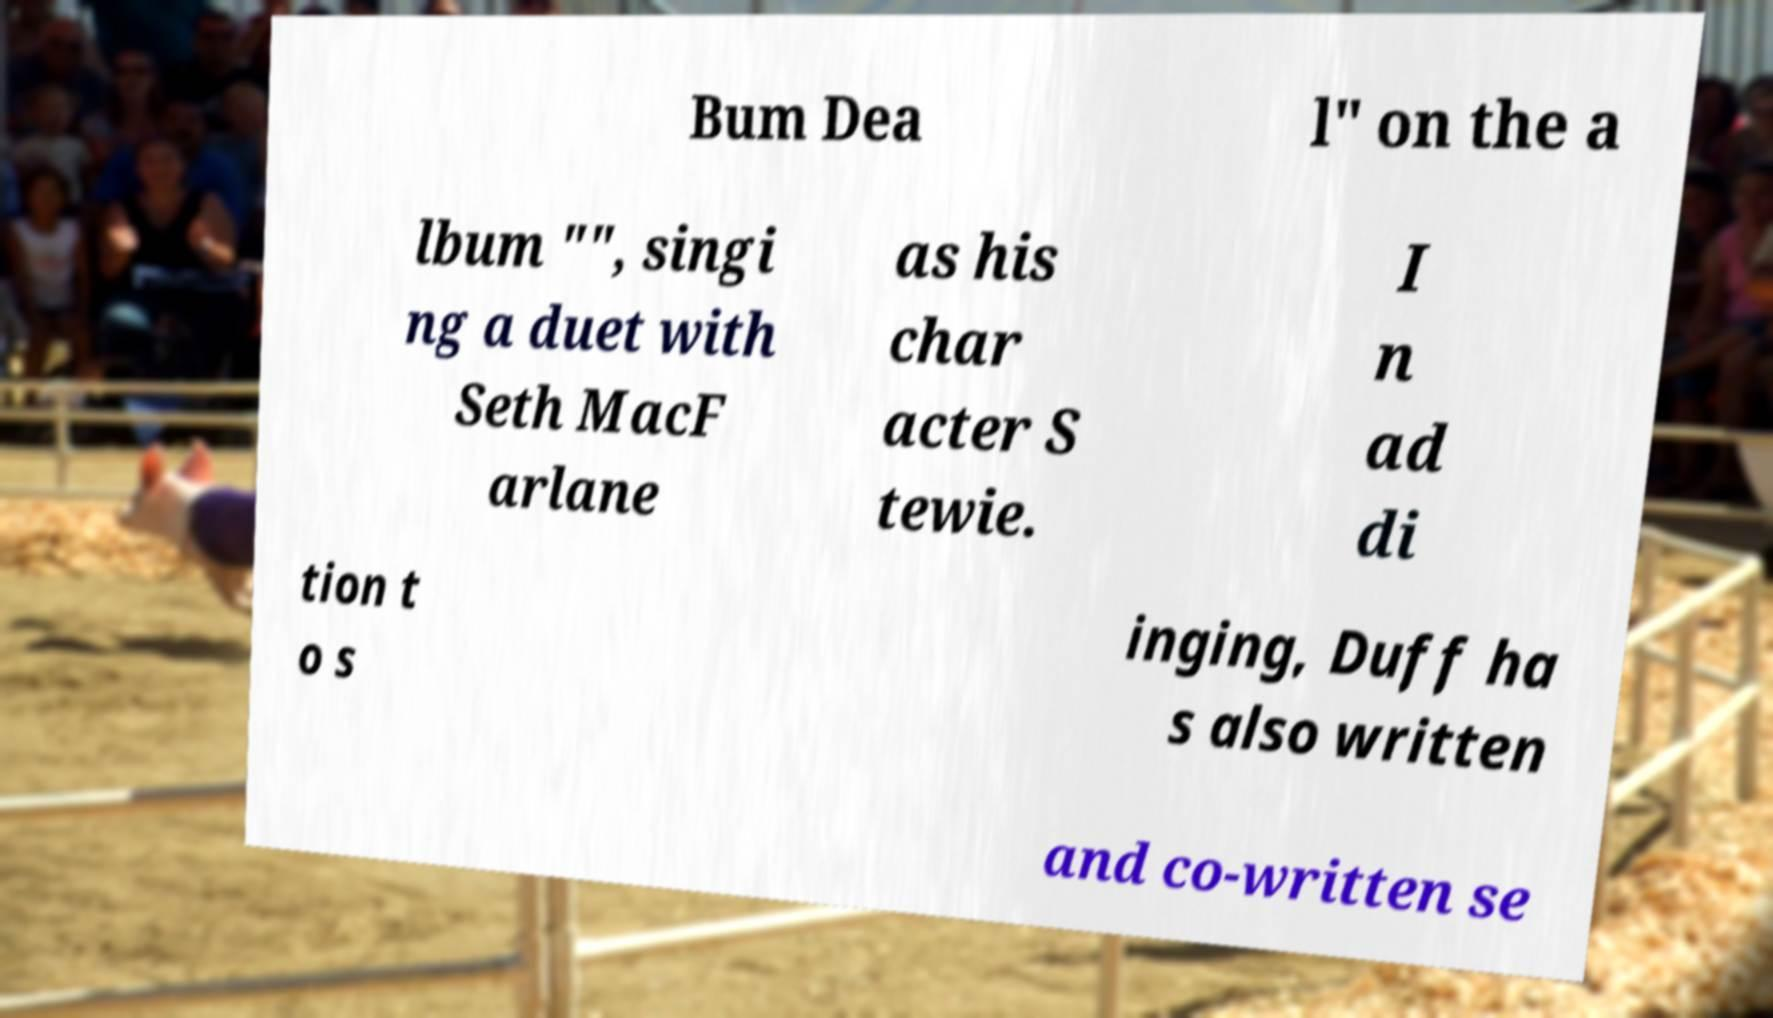Can you read and provide the text displayed in the image?This photo seems to have some interesting text. Can you extract and type it out for me? Bum Dea l" on the a lbum "", singi ng a duet with Seth MacF arlane as his char acter S tewie. I n ad di tion t o s inging, Duff ha s also written and co-written se 